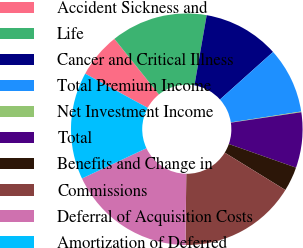<chart> <loc_0><loc_0><loc_500><loc_500><pie_chart><fcel>Accident Sickness and<fcel>Life<fcel>Cancer and Critical Illness<fcel>Total Premium Income<fcel>Net Investment Income<fcel>Total<fcel>Benefits and Change in<fcel>Commissions<fcel>Deferral of Acquisition Costs<fcel>Amortization of Deferred<nl><fcel>6.29%<fcel>13.5%<fcel>10.62%<fcel>9.18%<fcel>0.1%<fcel>7.73%<fcel>3.41%<fcel>16.39%<fcel>17.83%<fcel>14.95%<nl></chart> 